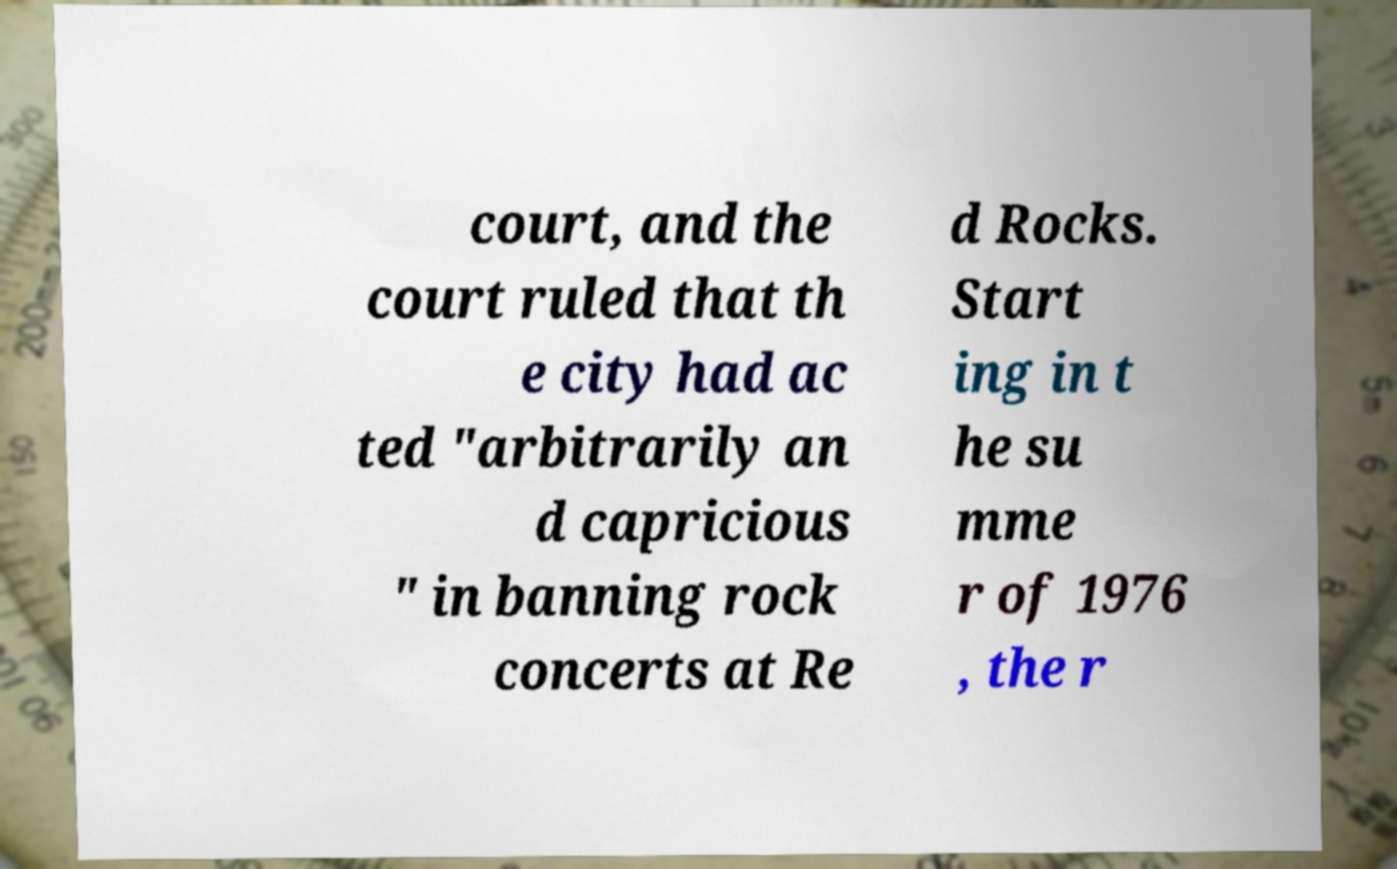Could you assist in decoding the text presented in this image and type it out clearly? court, and the court ruled that th e city had ac ted "arbitrarily an d capricious " in banning rock concerts at Re d Rocks. Start ing in t he su mme r of 1976 , the r 